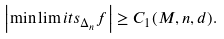Convert formula to latex. <formula><loc_0><loc_0><loc_500><loc_500>\left | \min \lim i t s _ { \Delta _ { n } } f \right | \geq C _ { 1 } ( M , n , d ) .</formula> 